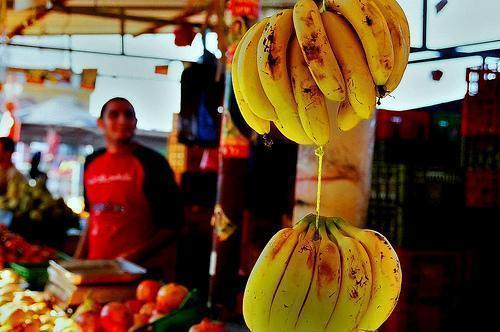What can hanging the bananas avoid?
Choose the right answer and clarify with the format: 'Answer: answer
Rationale: rationale.'
Options: Being damaged, black spots, being touched, being stolen. Answer: black spots.
Rationale: Bananas should be hung to slow down the ripening process and to prevent bruising. 